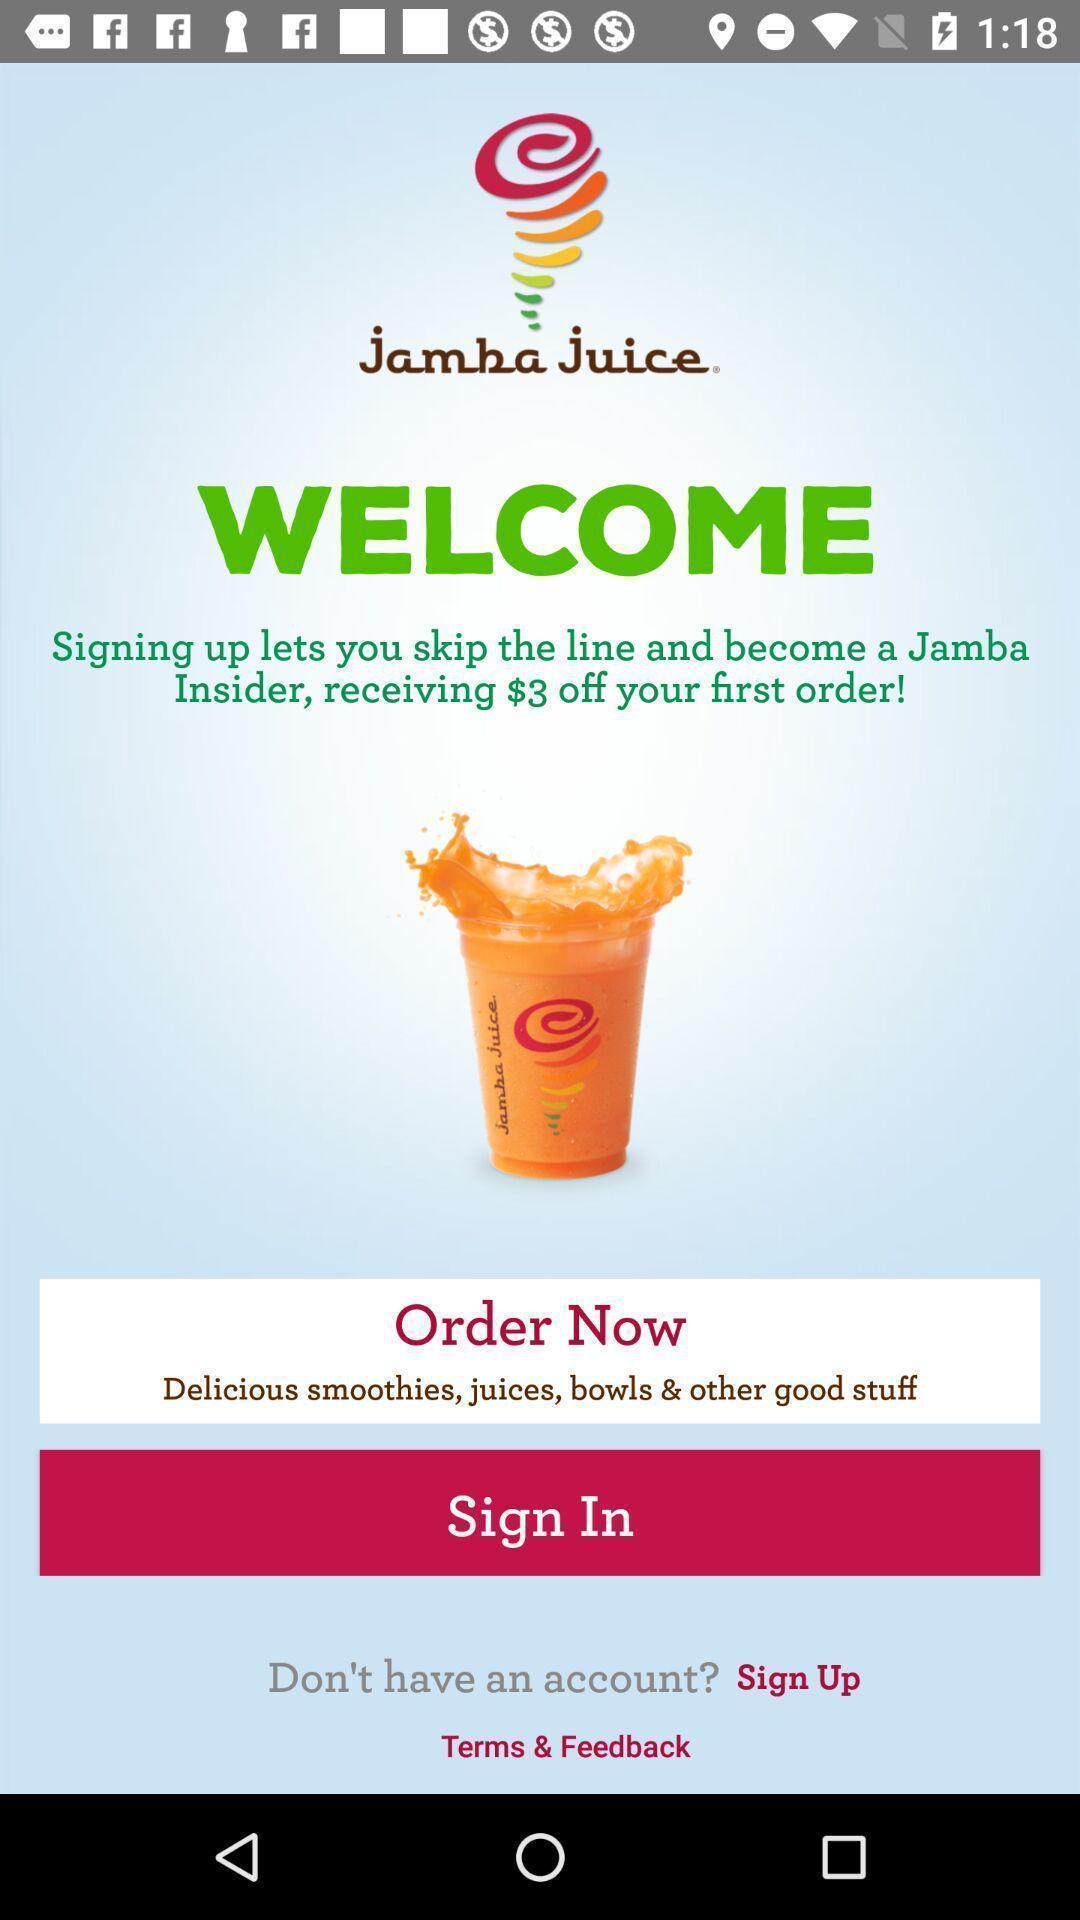Provide a textual representation of this image. Welcome page of a food app. 